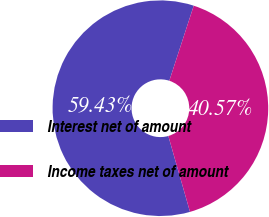Convert chart to OTSL. <chart><loc_0><loc_0><loc_500><loc_500><pie_chart><fcel>Interest net of amount<fcel>Income taxes net of amount<nl><fcel>59.43%<fcel>40.57%<nl></chart> 